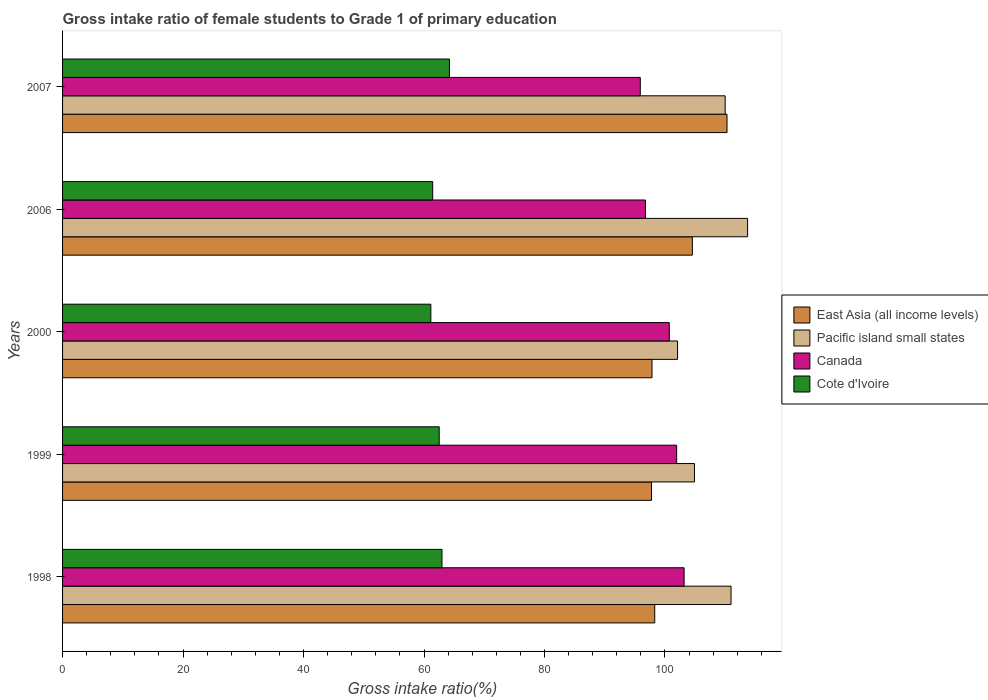Are the number of bars per tick equal to the number of legend labels?
Give a very brief answer. Yes. How many bars are there on the 3rd tick from the top?
Make the answer very short. 4. In how many cases, is the number of bars for a given year not equal to the number of legend labels?
Keep it short and to the point. 0. What is the gross intake ratio in Canada in 1999?
Your answer should be compact. 101.94. Across all years, what is the maximum gross intake ratio in Cote d'Ivoire?
Your answer should be very brief. 64.22. Across all years, what is the minimum gross intake ratio in Cote d'Ivoire?
Give a very brief answer. 61.14. In which year was the gross intake ratio in East Asia (all income levels) maximum?
Offer a very short reply. 2007. In which year was the gross intake ratio in East Asia (all income levels) minimum?
Your answer should be very brief. 1999. What is the total gross intake ratio in Cote d'Ivoire in the graph?
Make the answer very short. 312.31. What is the difference between the gross intake ratio in Canada in 2000 and that in 2006?
Your response must be concise. 3.95. What is the difference between the gross intake ratio in Cote d'Ivoire in 2007 and the gross intake ratio in Canada in 1999?
Give a very brief answer. -37.72. What is the average gross intake ratio in Canada per year?
Keep it short and to the point. 99.7. In the year 2000, what is the difference between the gross intake ratio in Cote d'Ivoire and gross intake ratio in East Asia (all income levels)?
Provide a succinct answer. -36.71. In how many years, is the gross intake ratio in Canada greater than 80 %?
Your answer should be compact. 5. What is the ratio of the gross intake ratio in Canada in 1998 to that in 2000?
Give a very brief answer. 1.02. Is the gross intake ratio in Canada in 1999 less than that in 2007?
Give a very brief answer. No. Is the difference between the gross intake ratio in Cote d'Ivoire in 2000 and 2006 greater than the difference between the gross intake ratio in East Asia (all income levels) in 2000 and 2006?
Your answer should be compact. Yes. What is the difference between the highest and the second highest gross intake ratio in Canada?
Give a very brief answer. 1.24. What is the difference between the highest and the lowest gross intake ratio in East Asia (all income levels)?
Your answer should be compact. 12.54. Is the sum of the gross intake ratio in Cote d'Ivoire in 1998 and 1999 greater than the maximum gross intake ratio in Pacific island small states across all years?
Provide a succinct answer. Yes. What does the 1st bar from the bottom in 2007 represents?
Offer a terse response. East Asia (all income levels). Is it the case that in every year, the sum of the gross intake ratio in Canada and gross intake ratio in East Asia (all income levels) is greater than the gross intake ratio in Pacific island small states?
Offer a very short reply. Yes. Are all the bars in the graph horizontal?
Your answer should be very brief. Yes. What is the difference between two consecutive major ticks on the X-axis?
Keep it short and to the point. 20. Are the values on the major ticks of X-axis written in scientific E-notation?
Your answer should be very brief. No. Does the graph contain any zero values?
Your answer should be very brief. No. How many legend labels are there?
Provide a succinct answer. 4. What is the title of the graph?
Ensure brevity in your answer.  Gross intake ratio of female students to Grade 1 of primary education. What is the label or title of the X-axis?
Ensure brevity in your answer.  Gross intake ratio(%). What is the label or title of the Y-axis?
Ensure brevity in your answer.  Years. What is the Gross intake ratio(%) of East Asia (all income levels) in 1998?
Your answer should be compact. 98.3. What is the Gross intake ratio(%) in Pacific island small states in 1998?
Keep it short and to the point. 110.97. What is the Gross intake ratio(%) of Canada in 1998?
Offer a terse response. 103.18. What is the Gross intake ratio(%) in Cote d'Ivoire in 1998?
Offer a very short reply. 62.98. What is the Gross intake ratio(%) of East Asia (all income levels) in 1999?
Offer a terse response. 97.76. What is the Gross intake ratio(%) in Pacific island small states in 1999?
Your response must be concise. 104.9. What is the Gross intake ratio(%) in Canada in 1999?
Your answer should be compact. 101.94. What is the Gross intake ratio(%) in Cote d'Ivoire in 1999?
Offer a terse response. 62.52. What is the Gross intake ratio(%) of East Asia (all income levels) in 2000?
Keep it short and to the point. 97.85. What is the Gross intake ratio(%) of Pacific island small states in 2000?
Give a very brief answer. 102.09. What is the Gross intake ratio(%) in Canada in 2000?
Provide a succinct answer. 100.72. What is the Gross intake ratio(%) in Cote d'Ivoire in 2000?
Ensure brevity in your answer.  61.14. What is the Gross intake ratio(%) of East Asia (all income levels) in 2006?
Keep it short and to the point. 104.55. What is the Gross intake ratio(%) in Pacific island small states in 2006?
Ensure brevity in your answer.  113.72. What is the Gross intake ratio(%) in Canada in 2006?
Ensure brevity in your answer.  96.76. What is the Gross intake ratio(%) in Cote d'Ivoire in 2006?
Make the answer very short. 61.44. What is the Gross intake ratio(%) in East Asia (all income levels) in 2007?
Your response must be concise. 110.3. What is the Gross intake ratio(%) in Pacific island small states in 2007?
Provide a short and direct response. 110. What is the Gross intake ratio(%) of Canada in 2007?
Your answer should be compact. 95.91. What is the Gross intake ratio(%) in Cote d'Ivoire in 2007?
Ensure brevity in your answer.  64.22. Across all years, what is the maximum Gross intake ratio(%) in East Asia (all income levels)?
Make the answer very short. 110.3. Across all years, what is the maximum Gross intake ratio(%) of Pacific island small states?
Give a very brief answer. 113.72. Across all years, what is the maximum Gross intake ratio(%) of Canada?
Make the answer very short. 103.18. Across all years, what is the maximum Gross intake ratio(%) in Cote d'Ivoire?
Provide a short and direct response. 64.22. Across all years, what is the minimum Gross intake ratio(%) in East Asia (all income levels)?
Your response must be concise. 97.76. Across all years, what is the minimum Gross intake ratio(%) of Pacific island small states?
Offer a terse response. 102.09. Across all years, what is the minimum Gross intake ratio(%) of Canada?
Your answer should be compact. 95.91. Across all years, what is the minimum Gross intake ratio(%) of Cote d'Ivoire?
Your answer should be very brief. 61.14. What is the total Gross intake ratio(%) in East Asia (all income levels) in the graph?
Your answer should be very brief. 508.76. What is the total Gross intake ratio(%) in Pacific island small states in the graph?
Give a very brief answer. 541.68. What is the total Gross intake ratio(%) in Canada in the graph?
Keep it short and to the point. 498.51. What is the total Gross intake ratio(%) in Cote d'Ivoire in the graph?
Keep it short and to the point. 312.31. What is the difference between the Gross intake ratio(%) in East Asia (all income levels) in 1998 and that in 1999?
Provide a short and direct response. 0.54. What is the difference between the Gross intake ratio(%) of Pacific island small states in 1998 and that in 1999?
Keep it short and to the point. 6.07. What is the difference between the Gross intake ratio(%) in Canada in 1998 and that in 1999?
Keep it short and to the point. 1.24. What is the difference between the Gross intake ratio(%) in Cote d'Ivoire in 1998 and that in 1999?
Give a very brief answer. 0.46. What is the difference between the Gross intake ratio(%) in East Asia (all income levels) in 1998 and that in 2000?
Provide a succinct answer. 0.46. What is the difference between the Gross intake ratio(%) in Pacific island small states in 1998 and that in 2000?
Make the answer very short. 8.88. What is the difference between the Gross intake ratio(%) of Canada in 1998 and that in 2000?
Your answer should be compact. 2.46. What is the difference between the Gross intake ratio(%) in Cote d'Ivoire in 1998 and that in 2000?
Give a very brief answer. 1.85. What is the difference between the Gross intake ratio(%) in East Asia (all income levels) in 1998 and that in 2006?
Your answer should be very brief. -6.24. What is the difference between the Gross intake ratio(%) in Pacific island small states in 1998 and that in 2006?
Give a very brief answer. -2.75. What is the difference between the Gross intake ratio(%) of Canada in 1998 and that in 2006?
Your answer should be compact. 6.41. What is the difference between the Gross intake ratio(%) of Cote d'Ivoire in 1998 and that in 2006?
Offer a terse response. 1.54. What is the difference between the Gross intake ratio(%) in East Asia (all income levels) in 1998 and that in 2007?
Your response must be concise. -12. What is the difference between the Gross intake ratio(%) in Pacific island small states in 1998 and that in 2007?
Make the answer very short. 0.97. What is the difference between the Gross intake ratio(%) in Canada in 1998 and that in 2007?
Offer a terse response. 7.27. What is the difference between the Gross intake ratio(%) of Cote d'Ivoire in 1998 and that in 2007?
Your answer should be compact. -1.24. What is the difference between the Gross intake ratio(%) in East Asia (all income levels) in 1999 and that in 2000?
Your response must be concise. -0.09. What is the difference between the Gross intake ratio(%) of Pacific island small states in 1999 and that in 2000?
Your response must be concise. 2.8. What is the difference between the Gross intake ratio(%) of Canada in 1999 and that in 2000?
Provide a succinct answer. 1.22. What is the difference between the Gross intake ratio(%) of Cote d'Ivoire in 1999 and that in 2000?
Give a very brief answer. 1.39. What is the difference between the Gross intake ratio(%) in East Asia (all income levels) in 1999 and that in 2006?
Provide a short and direct response. -6.79. What is the difference between the Gross intake ratio(%) of Pacific island small states in 1999 and that in 2006?
Your answer should be very brief. -8.82. What is the difference between the Gross intake ratio(%) in Canada in 1999 and that in 2006?
Keep it short and to the point. 5.18. What is the difference between the Gross intake ratio(%) of East Asia (all income levels) in 1999 and that in 2007?
Your response must be concise. -12.54. What is the difference between the Gross intake ratio(%) of Pacific island small states in 1999 and that in 2007?
Keep it short and to the point. -5.1. What is the difference between the Gross intake ratio(%) of Canada in 1999 and that in 2007?
Provide a short and direct response. 6.04. What is the difference between the Gross intake ratio(%) of Cote d'Ivoire in 1999 and that in 2007?
Ensure brevity in your answer.  -1.7. What is the difference between the Gross intake ratio(%) in East Asia (all income levels) in 2000 and that in 2006?
Keep it short and to the point. -6.7. What is the difference between the Gross intake ratio(%) of Pacific island small states in 2000 and that in 2006?
Provide a succinct answer. -11.63. What is the difference between the Gross intake ratio(%) of Canada in 2000 and that in 2006?
Offer a terse response. 3.95. What is the difference between the Gross intake ratio(%) of Cote d'Ivoire in 2000 and that in 2006?
Offer a terse response. -0.31. What is the difference between the Gross intake ratio(%) of East Asia (all income levels) in 2000 and that in 2007?
Keep it short and to the point. -12.45. What is the difference between the Gross intake ratio(%) of Pacific island small states in 2000 and that in 2007?
Your answer should be compact. -7.9. What is the difference between the Gross intake ratio(%) of Canada in 2000 and that in 2007?
Give a very brief answer. 4.81. What is the difference between the Gross intake ratio(%) in Cote d'Ivoire in 2000 and that in 2007?
Your answer should be very brief. -3.09. What is the difference between the Gross intake ratio(%) of East Asia (all income levels) in 2006 and that in 2007?
Give a very brief answer. -5.75. What is the difference between the Gross intake ratio(%) in Pacific island small states in 2006 and that in 2007?
Your answer should be very brief. 3.72. What is the difference between the Gross intake ratio(%) in Canada in 2006 and that in 2007?
Give a very brief answer. 0.86. What is the difference between the Gross intake ratio(%) in Cote d'Ivoire in 2006 and that in 2007?
Offer a very short reply. -2.78. What is the difference between the Gross intake ratio(%) of East Asia (all income levels) in 1998 and the Gross intake ratio(%) of Pacific island small states in 1999?
Give a very brief answer. -6.59. What is the difference between the Gross intake ratio(%) of East Asia (all income levels) in 1998 and the Gross intake ratio(%) of Canada in 1999?
Ensure brevity in your answer.  -3.64. What is the difference between the Gross intake ratio(%) of East Asia (all income levels) in 1998 and the Gross intake ratio(%) of Cote d'Ivoire in 1999?
Your answer should be very brief. 35.78. What is the difference between the Gross intake ratio(%) in Pacific island small states in 1998 and the Gross intake ratio(%) in Canada in 1999?
Keep it short and to the point. 9.03. What is the difference between the Gross intake ratio(%) in Pacific island small states in 1998 and the Gross intake ratio(%) in Cote d'Ivoire in 1999?
Ensure brevity in your answer.  48.45. What is the difference between the Gross intake ratio(%) in Canada in 1998 and the Gross intake ratio(%) in Cote d'Ivoire in 1999?
Your answer should be compact. 40.66. What is the difference between the Gross intake ratio(%) of East Asia (all income levels) in 1998 and the Gross intake ratio(%) of Pacific island small states in 2000?
Keep it short and to the point. -3.79. What is the difference between the Gross intake ratio(%) of East Asia (all income levels) in 1998 and the Gross intake ratio(%) of Canada in 2000?
Your answer should be very brief. -2.42. What is the difference between the Gross intake ratio(%) of East Asia (all income levels) in 1998 and the Gross intake ratio(%) of Cote d'Ivoire in 2000?
Ensure brevity in your answer.  37.17. What is the difference between the Gross intake ratio(%) of Pacific island small states in 1998 and the Gross intake ratio(%) of Canada in 2000?
Provide a succinct answer. 10.25. What is the difference between the Gross intake ratio(%) in Pacific island small states in 1998 and the Gross intake ratio(%) in Cote d'Ivoire in 2000?
Provide a succinct answer. 49.84. What is the difference between the Gross intake ratio(%) in Canada in 1998 and the Gross intake ratio(%) in Cote d'Ivoire in 2000?
Keep it short and to the point. 42.04. What is the difference between the Gross intake ratio(%) of East Asia (all income levels) in 1998 and the Gross intake ratio(%) of Pacific island small states in 2006?
Provide a succinct answer. -15.42. What is the difference between the Gross intake ratio(%) in East Asia (all income levels) in 1998 and the Gross intake ratio(%) in Canada in 2006?
Offer a terse response. 1.54. What is the difference between the Gross intake ratio(%) in East Asia (all income levels) in 1998 and the Gross intake ratio(%) in Cote d'Ivoire in 2006?
Offer a very short reply. 36.86. What is the difference between the Gross intake ratio(%) of Pacific island small states in 1998 and the Gross intake ratio(%) of Canada in 2006?
Your answer should be compact. 14.21. What is the difference between the Gross intake ratio(%) in Pacific island small states in 1998 and the Gross intake ratio(%) in Cote d'Ivoire in 2006?
Provide a short and direct response. 49.53. What is the difference between the Gross intake ratio(%) of Canada in 1998 and the Gross intake ratio(%) of Cote d'Ivoire in 2006?
Offer a terse response. 41.74. What is the difference between the Gross intake ratio(%) in East Asia (all income levels) in 1998 and the Gross intake ratio(%) in Pacific island small states in 2007?
Your answer should be compact. -11.69. What is the difference between the Gross intake ratio(%) of East Asia (all income levels) in 1998 and the Gross intake ratio(%) of Canada in 2007?
Your answer should be compact. 2.4. What is the difference between the Gross intake ratio(%) of East Asia (all income levels) in 1998 and the Gross intake ratio(%) of Cote d'Ivoire in 2007?
Offer a very short reply. 34.08. What is the difference between the Gross intake ratio(%) in Pacific island small states in 1998 and the Gross intake ratio(%) in Canada in 2007?
Offer a very short reply. 15.07. What is the difference between the Gross intake ratio(%) of Pacific island small states in 1998 and the Gross intake ratio(%) of Cote d'Ivoire in 2007?
Provide a short and direct response. 46.75. What is the difference between the Gross intake ratio(%) in Canada in 1998 and the Gross intake ratio(%) in Cote d'Ivoire in 2007?
Your answer should be very brief. 38.96. What is the difference between the Gross intake ratio(%) in East Asia (all income levels) in 1999 and the Gross intake ratio(%) in Pacific island small states in 2000?
Your answer should be very brief. -4.33. What is the difference between the Gross intake ratio(%) in East Asia (all income levels) in 1999 and the Gross intake ratio(%) in Canada in 2000?
Give a very brief answer. -2.96. What is the difference between the Gross intake ratio(%) in East Asia (all income levels) in 1999 and the Gross intake ratio(%) in Cote d'Ivoire in 2000?
Provide a short and direct response. 36.62. What is the difference between the Gross intake ratio(%) in Pacific island small states in 1999 and the Gross intake ratio(%) in Canada in 2000?
Your answer should be compact. 4.18. What is the difference between the Gross intake ratio(%) in Pacific island small states in 1999 and the Gross intake ratio(%) in Cote d'Ivoire in 2000?
Ensure brevity in your answer.  43.76. What is the difference between the Gross intake ratio(%) in Canada in 1999 and the Gross intake ratio(%) in Cote d'Ivoire in 2000?
Provide a short and direct response. 40.81. What is the difference between the Gross intake ratio(%) of East Asia (all income levels) in 1999 and the Gross intake ratio(%) of Pacific island small states in 2006?
Your response must be concise. -15.96. What is the difference between the Gross intake ratio(%) in East Asia (all income levels) in 1999 and the Gross intake ratio(%) in Canada in 2006?
Provide a succinct answer. 0.99. What is the difference between the Gross intake ratio(%) of East Asia (all income levels) in 1999 and the Gross intake ratio(%) of Cote d'Ivoire in 2006?
Make the answer very short. 36.32. What is the difference between the Gross intake ratio(%) in Pacific island small states in 1999 and the Gross intake ratio(%) in Canada in 2006?
Give a very brief answer. 8.13. What is the difference between the Gross intake ratio(%) in Pacific island small states in 1999 and the Gross intake ratio(%) in Cote d'Ivoire in 2006?
Offer a very short reply. 43.46. What is the difference between the Gross intake ratio(%) of Canada in 1999 and the Gross intake ratio(%) of Cote d'Ivoire in 2006?
Your response must be concise. 40.5. What is the difference between the Gross intake ratio(%) in East Asia (all income levels) in 1999 and the Gross intake ratio(%) in Pacific island small states in 2007?
Your answer should be very brief. -12.24. What is the difference between the Gross intake ratio(%) of East Asia (all income levels) in 1999 and the Gross intake ratio(%) of Canada in 2007?
Make the answer very short. 1.85. What is the difference between the Gross intake ratio(%) in East Asia (all income levels) in 1999 and the Gross intake ratio(%) in Cote d'Ivoire in 2007?
Your answer should be compact. 33.54. What is the difference between the Gross intake ratio(%) of Pacific island small states in 1999 and the Gross intake ratio(%) of Canada in 2007?
Keep it short and to the point. 8.99. What is the difference between the Gross intake ratio(%) in Pacific island small states in 1999 and the Gross intake ratio(%) in Cote d'Ivoire in 2007?
Give a very brief answer. 40.68. What is the difference between the Gross intake ratio(%) of Canada in 1999 and the Gross intake ratio(%) of Cote d'Ivoire in 2007?
Keep it short and to the point. 37.72. What is the difference between the Gross intake ratio(%) in East Asia (all income levels) in 2000 and the Gross intake ratio(%) in Pacific island small states in 2006?
Your response must be concise. -15.87. What is the difference between the Gross intake ratio(%) in East Asia (all income levels) in 2000 and the Gross intake ratio(%) in Canada in 2006?
Provide a short and direct response. 1.08. What is the difference between the Gross intake ratio(%) of East Asia (all income levels) in 2000 and the Gross intake ratio(%) of Cote d'Ivoire in 2006?
Keep it short and to the point. 36.41. What is the difference between the Gross intake ratio(%) of Pacific island small states in 2000 and the Gross intake ratio(%) of Canada in 2006?
Your response must be concise. 5.33. What is the difference between the Gross intake ratio(%) in Pacific island small states in 2000 and the Gross intake ratio(%) in Cote d'Ivoire in 2006?
Give a very brief answer. 40.65. What is the difference between the Gross intake ratio(%) of Canada in 2000 and the Gross intake ratio(%) of Cote d'Ivoire in 2006?
Make the answer very short. 39.28. What is the difference between the Gross intake ratio(%) of East Asia (all income levels) in 2000 and the Gross intake ratio(%) of Pacific island small states in 2007?
Ensure brevity in your answer.  -12.15. What is the difference between the Gross intake ratio(%) in East Asia (all income levels) in 2000 and the Gross intake ratio(%) in Canada in 2007?
Your answer should be compact. 1.94. What is the difference between the Gross intake ratio(%) in East Asia (all income levels) in 2000 and the Gross intake ratio(%) in Cote d'Ivoire in 2007?
Provide a succinct answer. 33.63. What is the difference between the Gross intake ratio(%) in Pacific island small states in 2000 and the Gross intake ratio(%) in Canada in 2007?
Provide a succinct answer. 6.19. What is the difference between the Gross intake ratio(%) in Pacific island small states in 2000 and the Gross intake ratio(%) in Cote d'Ivoire in 2007?
Make the answer very short. 37.87. What is the difference between the Gross intake ratio(%) of Canada in 2000 and the Gross intake ratio(%) of Cote d'Ivoire in 2007?
Give a very brief answer. 36.5. What is the difference between the Gross intake ratio(%) in East Asia (all income levels) in 2006 and the Gross intake ratio(%) in Pacific island small states in 2007?
Give a very brief answer. -5.45. What is the difference between the Gross intake ratio(%) in East Asia (all income levels) in 2006 and the Gross intake ratio(%) in Canada in 2007?
Your response must be concise. 8.64. What is the difference between the Gross intake ratio(%) of East Asia (all income levels) in 2006 and the Gross intake ratio(%) of Cote d'Ivoire in 2007?
Give a very brief answer. 40.33. What is the difference between the Gross intake ratio(%) of Pacific island small states in 2006 and the Gross intake ratio(%) of Canada in 2007?
Your response must be concise. 17.82. What is the difference between the Gross intake ratio(%) of Pacific island small states in 2006 and the Gross intake ratio(%) of Cote d'Ivoire in 2007?
Your response must be concise. 49.5. What is the difference between the Gross intake ratio(%) in Canada in 2006 and the Gross intake ratio(%) in Cote d'Ivoire in 2007?
Give a very brief answer. 32.54. What is the average Gross intake ratio(%) in East Asia (all income levels) per year?
Ensure brevity in your answer.  101.75. What is the average Gross intake ratio(%) of Pacific island small states per year?
Your response must be concise. 108.34. What is the average Gross intake ratio(%) of Canada per year?
Your answer should be very brief. 99.7. What is the average Gross intake ratio(%) of Cote d'Ivoire per year?
Give a very brief answer. 62.46. In the year 1998, what is the difference between the Gross intake ratio(%) of East Asia (all income levels) and Gross intake ratio(%) of Pacific island small states?
Your answer should be very brief. -12.67. In the year 1998, what is the difference between the Gross intake ratio(%) in East Asia (all income levels) and Gross intake ratio(%) in Canada?
Ensure brevity in your answer.  -4.87. In the year 1998, what is the difference between the Gross intake ratio(%) in East Asia (all income levels) and Gross intake ratio(%) in Cote d'Ivoire?
Offer a terse response. 35.32. In the year 1998, what is the difference between the Gross intake ratio(%) in Pacific island small states and Gross intake ratio(%) in Canada?
Make the answer very short. 7.79. In the year 1998, what is the difference between the Gross intake ratio(%) in Pacific island small states and Gross intake ratio(%) in Cote d'Ivoire?
Provide a short and direct response. 47.99. In the year 1998, what is the difference between the Gross intake ratio(%) of Canada and Gross intake ratio(%) of Cote d'Ivoire?
Your response must be concise. 40.19. In the year 1999, what is the difference between the Gross intake ratio(%) of East Asia (all income levels) and Gross intake ratio(%) of Pacific island small states?
Ensure brevity in your answer.  -7.14. In the year 1999, what is the difference between the Gross intake ratio(%) of East Asia (all income levels) and Gross intake ratio(%) of Canada?
Keep it short and to the point. -4.18. In the year 1999, what is the difference between the Gross intake ratio(%) of East Asia (all income levels) and Gross intake ratio(%) of Cote d'Ivoire?
Ensure brevity in your answer.  35.24. In the year 1999, what is the difference between the Gross intake ratio(%) in Pacific island small states and Gross intake ratio(%) in Canada?
Offer a terse response. 2.96. In the year 1999, what is the difference between the Gross intake ratio(%) in Pacific island small states and Gross intake ratio(%) in Cote d'Ivoire?
Make the answer very short. 42.38. In the year 1999, what is the difference between the Gross intake ratio(%) of Canada and Gross intake ratio(%) of Cote d'Ivoire?
Provide a short and direct response. 39.42. In the year 2000, what is the difference between the Gross intake ratio(%) of East Asia (all income levels) and Gross intake ratio(%) of Pacific island small states?
Provide a short and direct response. -4.25. In the year 2000, what is the difference between the Gross intake ratio(%) in East Asia (all income levels) and Gross intake ratio(%) in Canada?
Offer a very short reply. -2.87. In the year 2000, what is the difference between the Gross intake ratio(%) in East Asia (all income levels) and Gross intake ratio(%) in Cote d'Ivoire?
Offer a very short reply. 36.71. In the year 2000, what is the difference between the Gross intake ratio(%) of Pacific island small states and Gross intake ratio(%) of Canada?
Your answer should be very brief. 1.37. In the year 2000, what is the difference between the Gross intake ratio(%) of Pacific island small states and Gross intake ratio(%) of Cote d'Ivoire?
Offer a very short reply. 40.96. In the year 2000, what is the difference between the Gross intake ratio(%) of Canada and Gross intake ratio(%) of Cote d'Ivoire?
Offer a very short reply. 39.58. In the year 2006, what is the difference between the Gross intake ratio(%) in East Asia (all income levels) and Gross intake ratio(%) in Pacific island small states?
Your answer should be very brief. -9.17. In the year 2006, what is the difference between the Gross intake ratio(%) in East Asia (all income levels) and Gross intake ratio(%) in Canada?
Your answer should be very brief. 7.78. In the year 2006, what is the difference between the Gross intake ratio(%) of East Asia (all income levels) and Gross intake ratio(%) of Cote d'Ivoire?
Offer a very short reply. 43.1. In the year 2006, what is the difference between the Gross intake ratio(%) of Pacific island small states and Gross intake ratio(%) of Canada?
Offer a terse response. 16.96. In the year 2006, what is the difference between the Gross intake ratio(%) in Pacific island small states and Gross intake ratio(%) in Cote d'Ivoire?
Provide a short and direct response. 52.28. In the year 2006, what is the difference between the Gross intake ratio(%) of Canada and Gross intake ratio(%) of Cote d'Ivoire?
Give a very brief answer. 35.32. In the year 2007, what is the difference between the Gross intake ratio(%) in East Asia (all income levels) and Gross intake ratio(%) in Pacific island small states?
Make the answer very short. 0.3. In the year 2007, what is the difference between the Gross intake ratio(%) of East Asia (all income levels) and Gross intake ratio(%) of Canada?
Provide a succinct answer. 14.4. In the year 2007, what is the difference between the Gross intake ratio(%) in East Asia (all income levels) and Gross intake ratio(%) in Cote d'Ivoire?
Provide a short and direct response. 46.08. In the year 2007, what is the difference between the Gross intake ratio(%) in Pacific island small states and Gross intake ratio(%) in Canada?
Give a very brief answer. 14.09. In the year 2007, what is the difference between the Gross intake ratio(%) in Pacific island small states and Gross intake ratio(%) in Cote d'Ivoire?
Offer a very short reply. 45.78. In the year 2007, what is the difference between the Gross intake ratio(%) in Canada and Gross intake ratio(%) in Cote d'Ivoire?
Provide a succinct answer. 31.68. What is the ratio of the Gross intake ratio(%) of East Asia (all income levels) in 1998 to that in 1999?
Provide a short and direct response. 1.01. What is the ratio of the Gross intake ratio(%) of Pacific island small states in 1998 to that in 1999?
Your answer should be compact. 1.06. What is the ratio of the Gross intake ratio(%) in Canada in 1998 to that in 1999?
Your answer should be very brief. 1.01. What is the ratio of the Gross intake ratio(%) in Cote d'Ivoire in 1998 to that in 1999?
Provide a short and direct response. 1.01. What is the ratio of the Gross intake ratio(%) in East Asia (all income levels) in 1998 to that in 2000?
Give a very brief answer. 1. What is the ratio of the Gross intake ratio(%) in Pacific island small states in 1998 to that in 2000?
Make the answer very short. 1.09. What is the ratio of the Gross intake ratio(%) in Canada in 1998 to that in 2000?
Make the answer very short. 1.02. What is the ratio of the Gross intake ratio(%) in Cote d'Ivoire in 1998 to that in 2000?
Your answer should be very brief. 1.03. What is the ratio of the Gross intake ratio(%) of East Asia (all income levels) in 1998 to that in 2006?
Provide a short and direct response. 0.94. What is the ratio of the Gross intake ratio(%) in Pacific island small states in 1998 to that in 2006?
Your answer should be very brief. 0.98. What is the ratio of the Gross intake ratio(%) in Canada in 1998 to that in 2006?
Give a very brief answer. 1.07. What is the ratio of the Gross intake ratio(%) in Cote d'Ivoire in 1998 to that in 2006?
Your response must be concise. 1.03. What is the ratio of the Gross intake ratio(%) in East Asia (all income levels) in 1998 to that in 2007?
Give a very brief answer. 0.89. What is the ratio of the Gross intake ratio(%) in Pacific island small states in 1998 to that in 2007?
Offer a very short reply. 1.01. What is the ratio of the Gross intake ratio(%) of Canada in 1998 to that in 2007?
Offer a very short reply. 1.08. What is the ratio of the Gross intake ratio(%) in Cote d'Ivoire in 1998 to that in 2007?
Your response must be concise. 0.98. What is the ratio of the Gross intake ratio(%) of Pacific island small states in 1999 to that in 2000?
Ensure brevity in your answer.  1.03. What is the ratio of the Gross intake ratio(%) in Canada in 1999 to that in 2000?
Provide a short and direct response. 1.01. What is the ratio of the Gross intake ratio(%) of Cote d'Ivoire in 1999 to that in 2000?
Offer a terse response. 1.02. What is the ratio of the Gross intake ratio(%) in East Asia (all income levels) in 1999 to that in 2006?
Give a very brief answer. 0.94. What is the ratio of the Gross intake ratio(%) in Pacific island small states in 1999 to that in 2006?
Offer a terse response. 0.92. What is the ratio of the Gross intake ratio(%) in Canada in 1999 to that in 2006?
Give a very brief answer. 1.05. What is the ratio of the Gross intake ratio(%) of Cote d'Ivoire in 1999 to that in 2006?
Provide a succinct answer. 1.02. What is the ratio of the Gross intake ratio(%) in East Asia (all income levels) in 1999 to that in 2007?
Make the answer very short. 0.89. What is the ratio of the Gross intake ratio(%) in Pacific island small states in 1999 to that in 2007?
Provide a short and direct response. 0.95. What is the ratio of the Gross intake ratio(%) of Canada in 1999 to that in 2007?
Make the answer very short. 1.06. What is the ratio of the Gross intake ratio(%) of Cote d'Ivoire in 1999 to that in 2007?
Keep it short and to the point. 0.97. What is the ratio of the Gross intake ratio(%) in East Asia (all income levels) in 2000 to that in 2006?
Make the answer very short. 0.94. What is the ratio of the Gross intake ratio(%) in Pacific island small states in 2000 to that in 2006?
Your response must be concise. 0.9. What is the ratio of the Gross intake ratio(%) in Canada in 2000 to that in 2006?
Give a very brief answer. 1.04. What is the ratio of the Gross intake ratio(%) of East Asia (all income levels) in 2000 to that in 2007?
Your response must be concise. 0.89. What is the ratio of the Gross intake ratio(%) in Pacific island small states in 2000 to that in 2007?
Your response must be concise. 0.93. What is the ratio of the Gross intake ratio(%) of Canada in 2000 to that in 2007?
Your response must be concise. 1.05. What is the ratio of the Gross intake ratio(%) in Cote d'Ivoire in 2000 to that in 2007?
Provide a short and direct response. 0.95. What is the ratio of the Gross intake ratio(%) in East Asia (all income levels) in 2006 to that in 2007?
Offer a terse response. 0.95. What is the ratio of the Gross intake ratio(%) of Pacific island small states in 2006 to that in 2007?
Offer a very short reply. 1.03. What is the ratio of the Gross intake ratio(%) of Cote d'Ivoire in 2006 to that in 2007?
Your answer should be compact. 0.96. What is the difference between the highest and the second highest Gross intake ratio(%) in East Asia (all income levels)?
Offer a terse response. 5.75. What is the difference between the highest and the second highest Gross intake ratio(%) in Pacific island small states?
Your response must be concise. 2.75. What is the difference between the highest and the second highest Gross intake ratio(%) in Canada?
Provide a succinct answer. 1.24. What is the difference between the highest and the second highest Gross intake ratio(%) in Cote d'Ivoire?
Provide a short and direct response. 1.24. What is the difference between the highest and the lowest Gross intake ratio(%) of East Asia (all income levels)?
Your answer should be very brief. 12.54. What is the difference between the highest and the lowest Gross intake ratio(%) in Pacific island small states?
Offer a terse response. 11.63. What is the difference between the highest and the lowest Gross intake ratio(%) of Canada?
Offer a very short reply. 7.27. What is the difference between the highest and the lowest Gross intake ratio(%) in Cote d'Ivoire?
Ensure brevity in your answer.  3.09. 